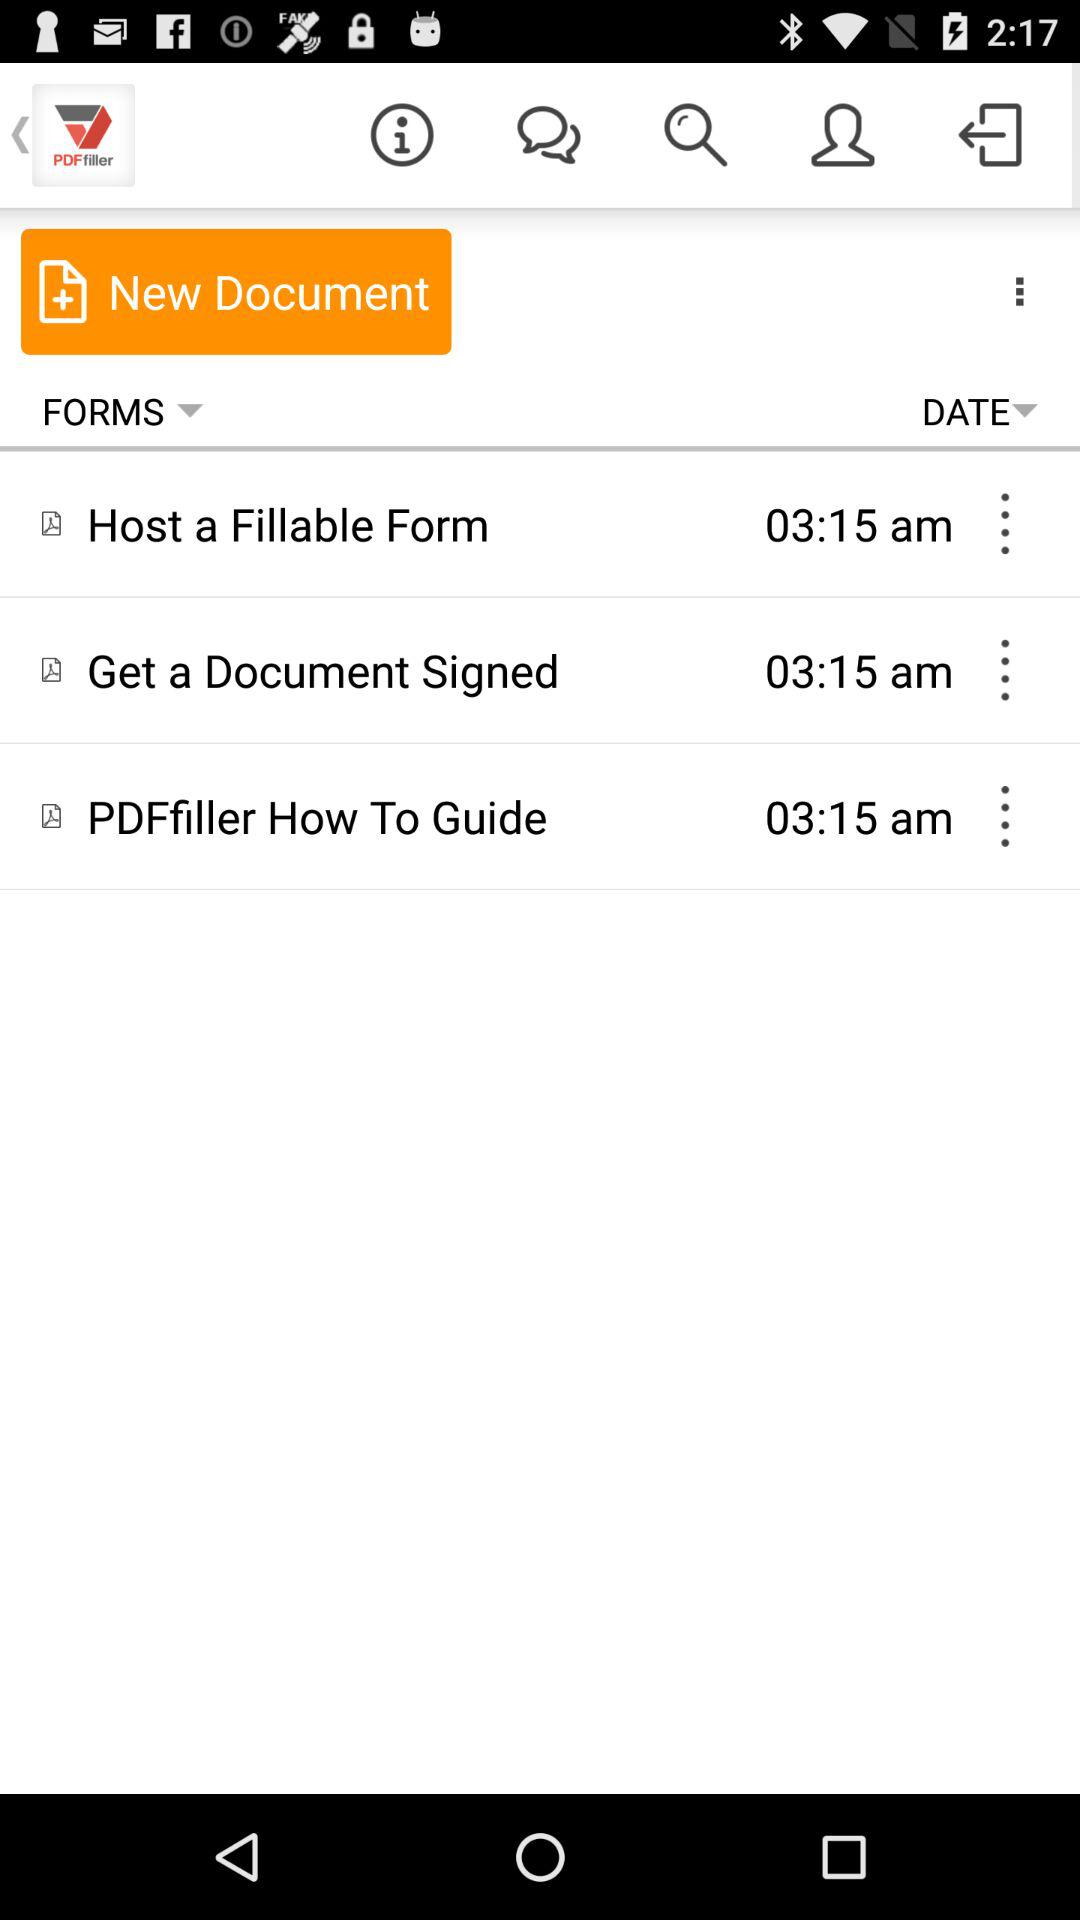What is the application name? The application name is "PDF filler". 